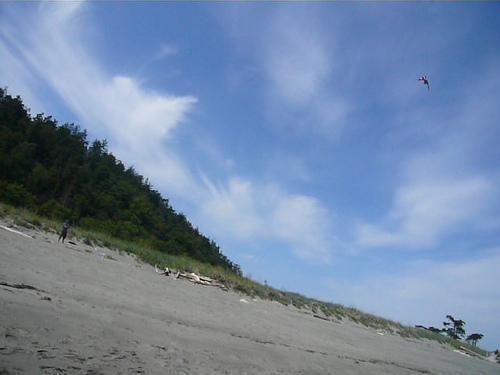How many rocks are shown?
Give a very brief answer. 0. 